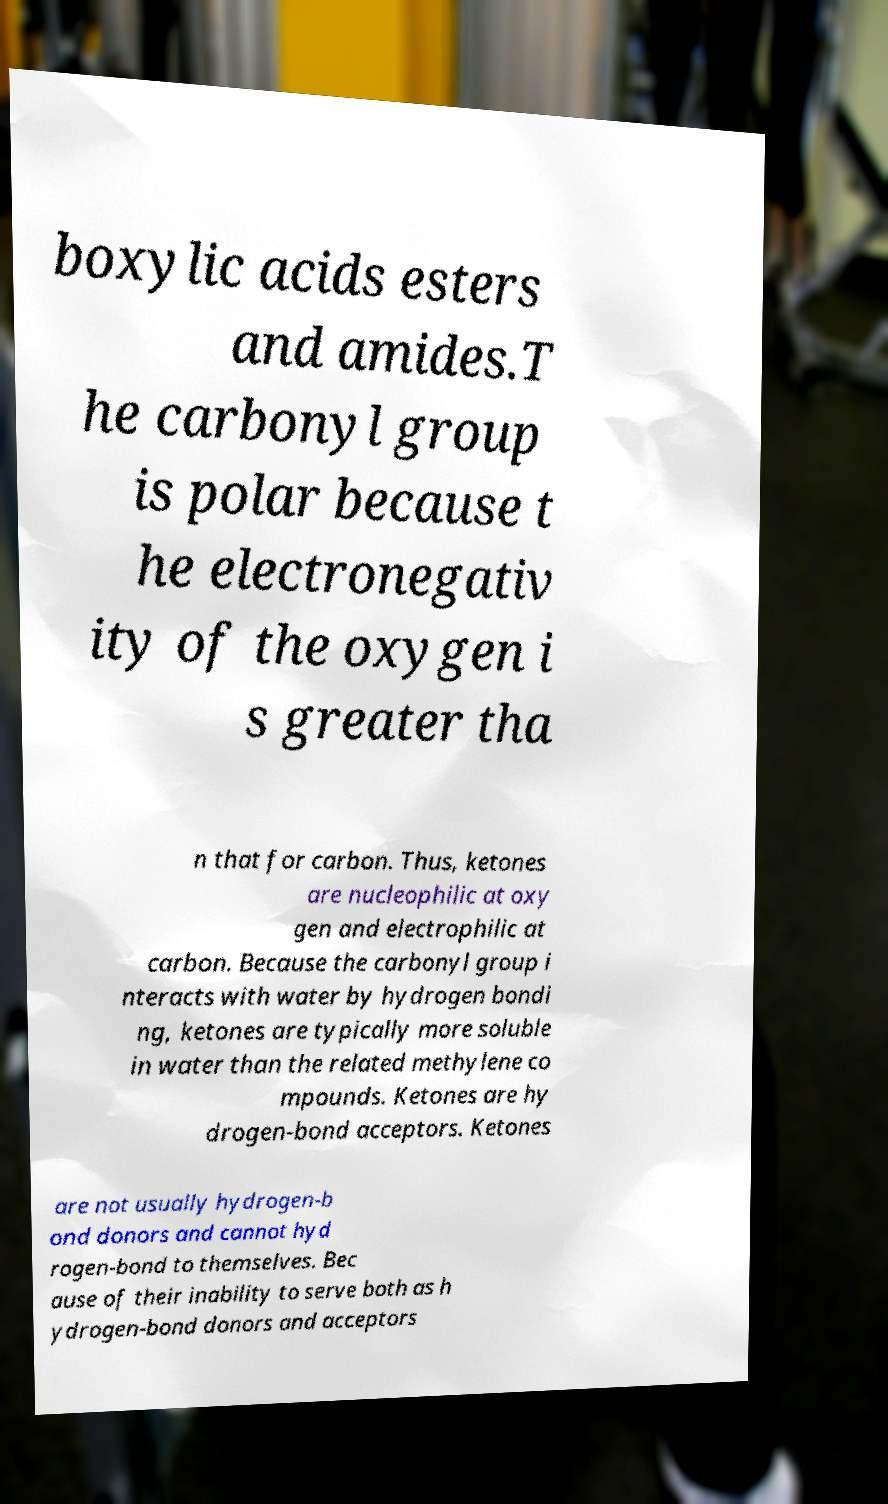Please identify and transcribe the text found in this image. boxylic acids esters and amides.T he carbonyl group is polar because t he electronegativ ity of the oxygen i s greater tha n that for carbon. Thus, ketones are nucleophilic at oxy gen and electrophilic at carbon. Because the carbonyl group i nteracts with water by hydrogen bondi ng, ketones are typically more soluble in water than the related methylene co mpounds. Ketones are hy drogen-bond acceptors. Ketones are not usually hydrogen-b ond donors and cannot hyd rogen-bond to themselves. Bec ause of their inability to serve both as h ydrogen-bond donors and acceptors 